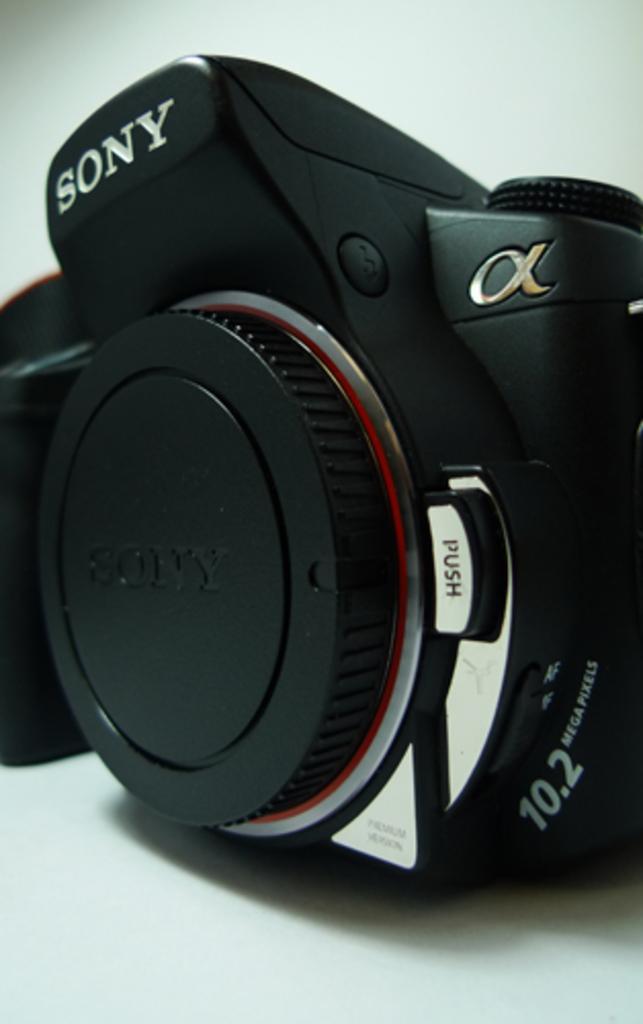Could you give a brief overview of what you see in this image? This is camera, this is white color background. 